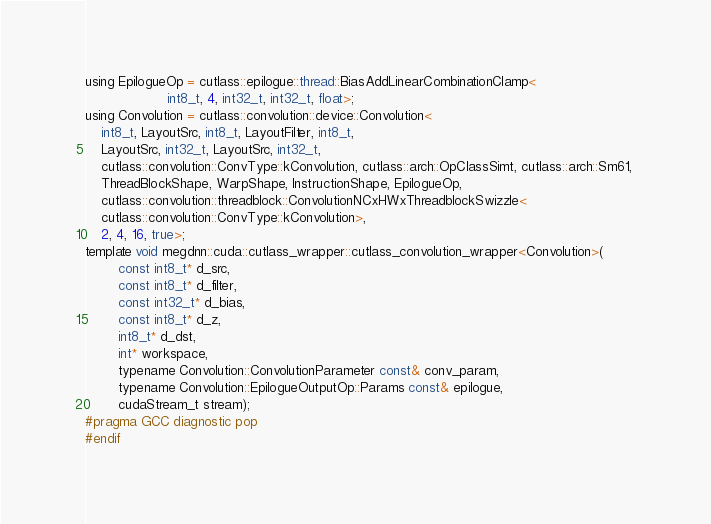Convert code to text. <code><loc_0><loc_0><loc_500><loc_500><_Cuda_>using EpilogueOp = cutlass::epilogue::thread::BiasAddLinearCombinationClamp<
                    int8_t, 4, int32_t, int32_t, float>;
using Convolution = cutlass::convolution::device::Convolution<
    int8_t, LayoutSrc, int8_t, LayoutFilter, int8_t, 
    LayoutSrc, int32_t, LayoutSrc, int32_t, 
    cutlass::convolution::ConvType::kConvolution, cutlass::arch::OpClassSimt, cutlass::arch::Sm61, 
    ThreadBlockShape, WarpShape, InstructionShape, EpilogueOp, 
    cutlass::convolution::threadblock::ConvolutionNCxHWxThreadblockSwizzle<
    cutlass::convolution::ConvType::kConvolution>, 
    2, 4, 16, true>;
template void megdnn::cuda::cutlass_wrapper::cutlass_convolution_wrapper<Convolution>(
        const int8_t* d_src, 
        const int8_t* d_filter, 
        const int32_t* d_bias, 
        const int8_t* d_z, 
        int8_t* d_dst, 
        int* workspace, 
        typename Convolution::ConvolutionParameter const& conv_param, 
        typename Convolution::EpilogueOutputOp::Params const& epilogue, 
        cudaStream_t stream);
#pragma GCC diagnostic pop
#endif
</code> 